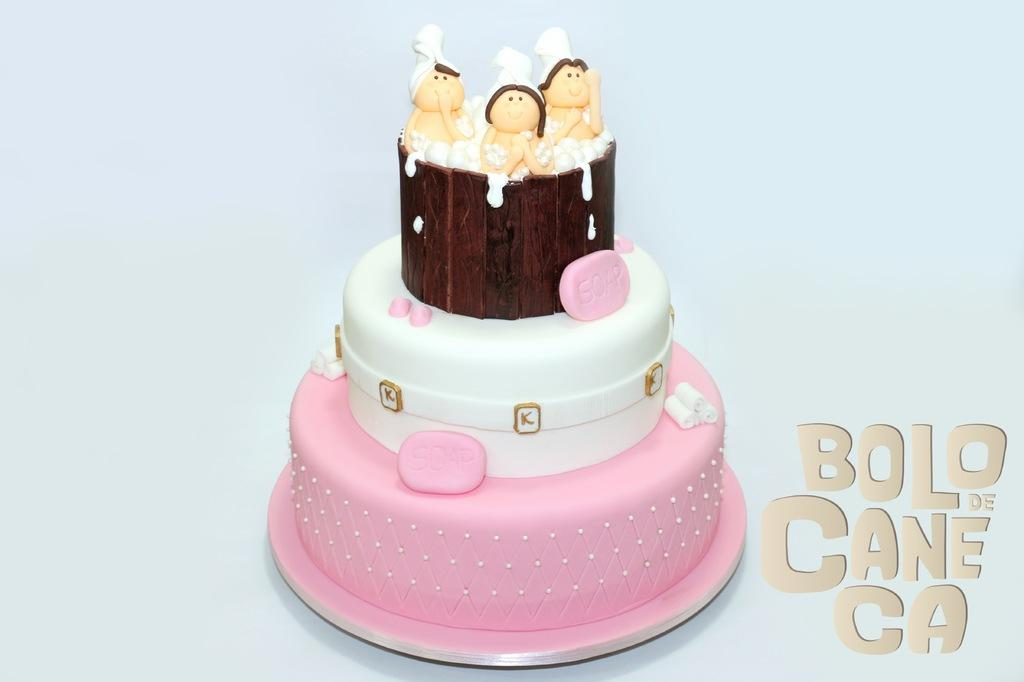What is the main subject of the image? There is a cake in the image. Can you describe the color of the cake? The cake has a white and pink color. What additional items are on the cake? There are toys on the cake. How many feet can be seen on the cake in the image? There are no feet visible on the cake in the image. What type of cherry is placed on top of the cake? There is no cherry present on the cake in the image. 